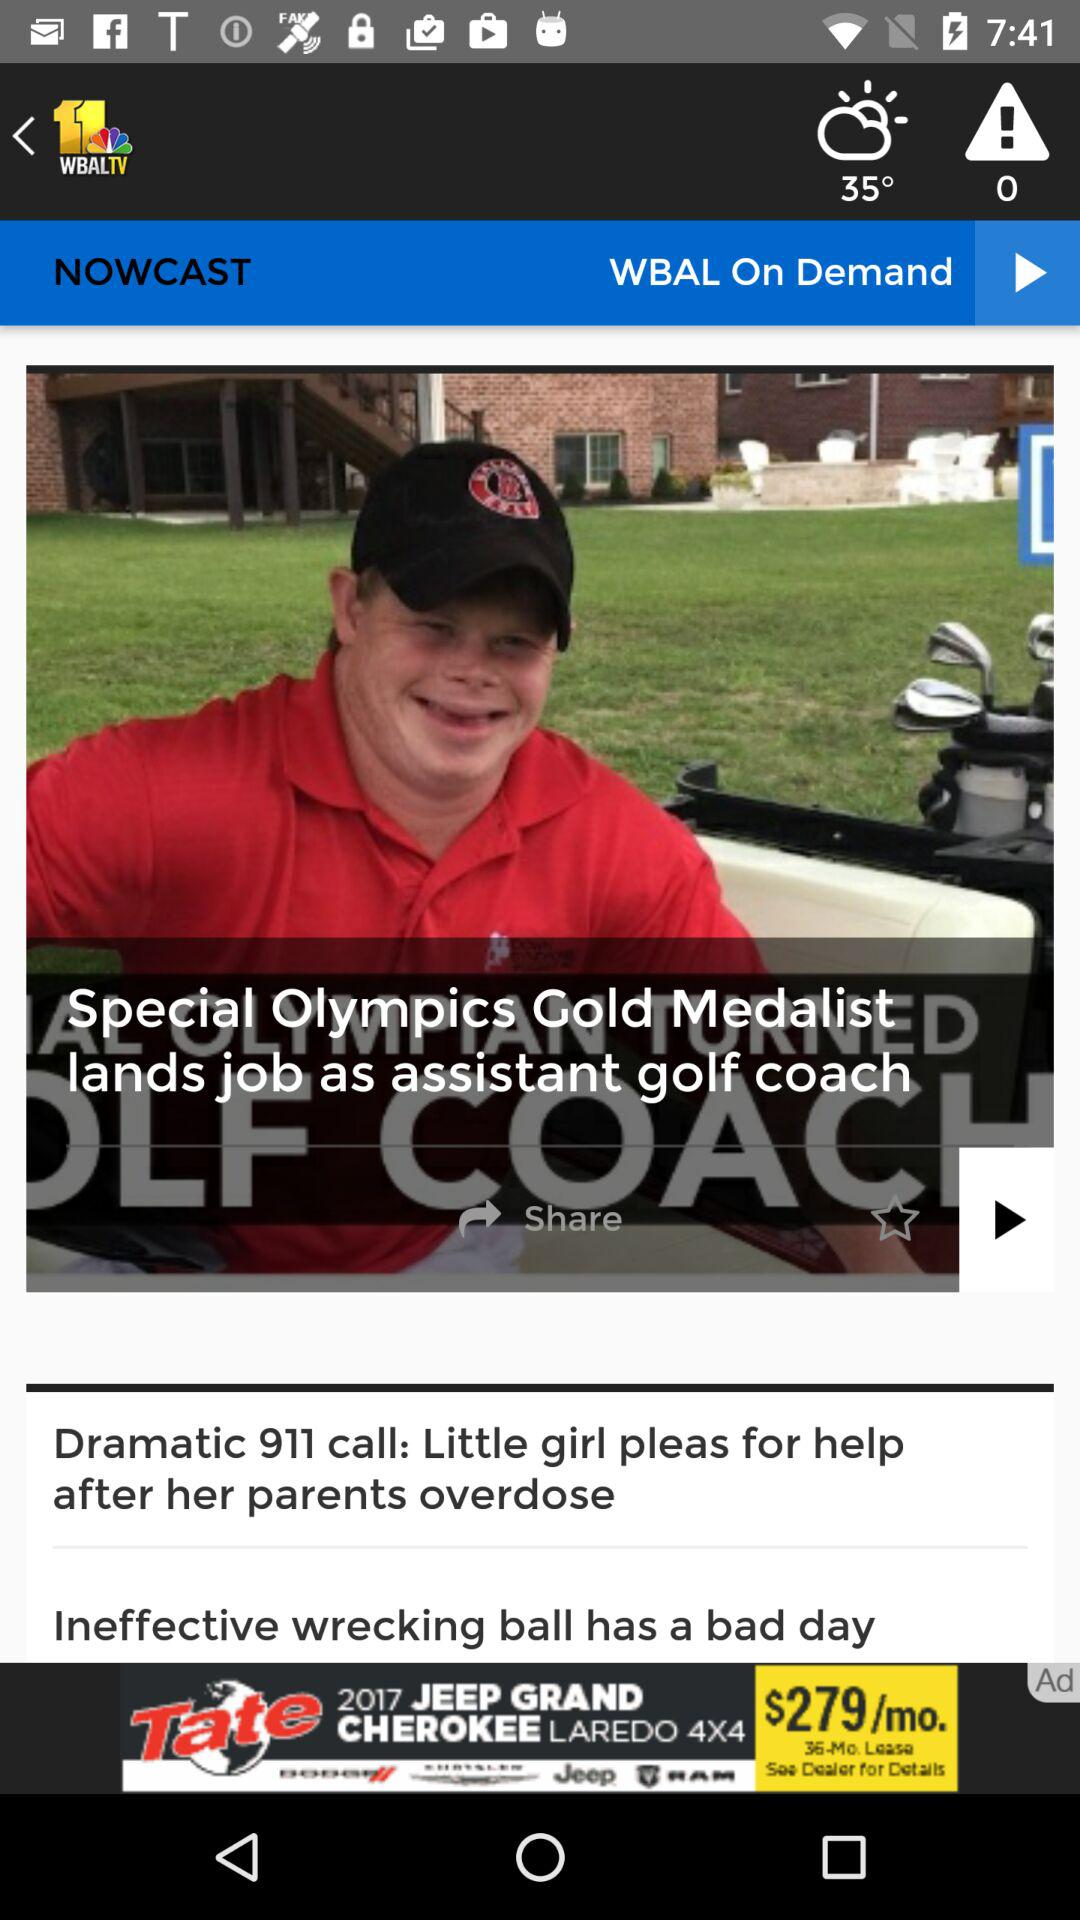How many degrees is the weather?
Answer the question using a single word or phrase. 35° 